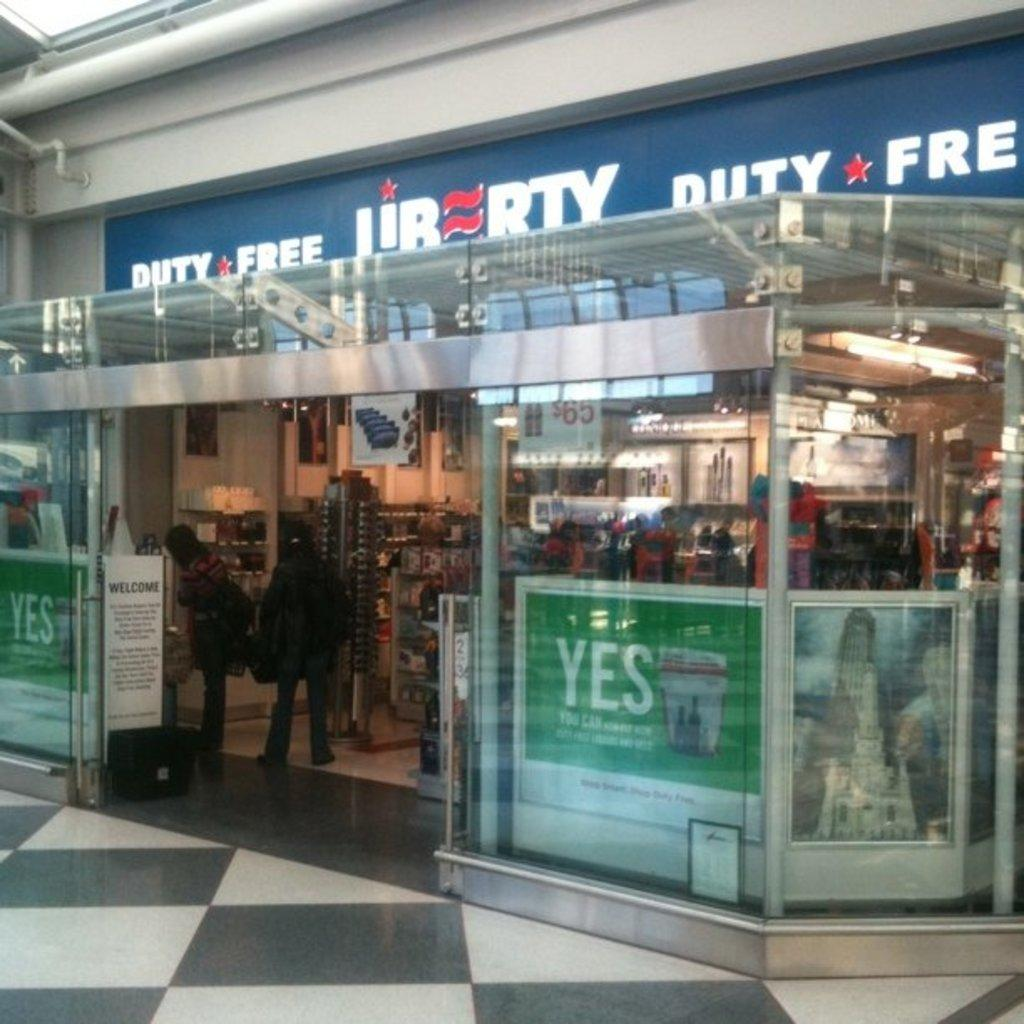<image>
Create a compact narrative representing the image presented. A store, called Liberty Duty Free, features green signs in the windows. 